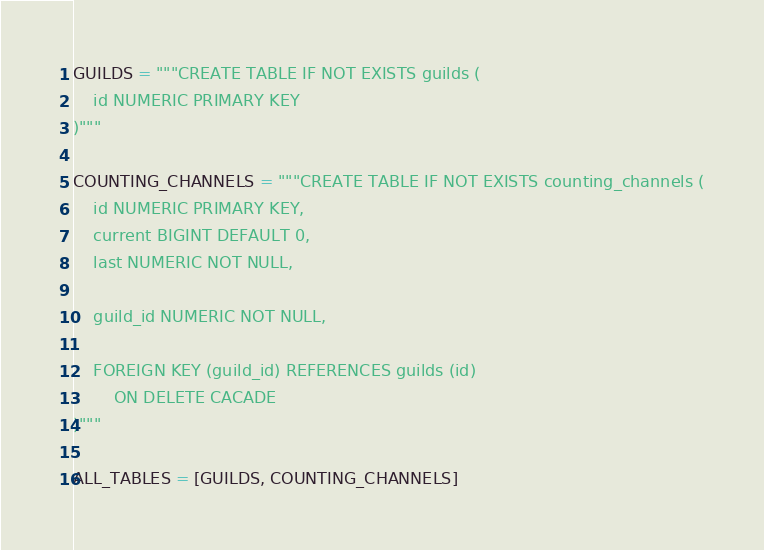Convert code to text. <code><loc_0><loc_0><loc_500><loc_500><_Python_>GUILDS = """CREATE TABLE IF NOT EXISTS guilds (
    id NUMERIC PRIMARY KEY
)"""

COUNTING_CHANNELS = """CREATE TABLE IF NOT EXISTS counting_channels (
    id NUMERIC PRIMARY KEY,
    current BIGINT DEFAULT 0,
    last NUMERIC NOT NULL,

    guild_id NUMERIC NOT NULL,

    FOREIGN KEY (guild_id) REFERENCES guilds (id)
        ON DELETE CACADE
)"""

ALL_TABLES = [GUILDS, COUNTING_CHANNELS]
</code> 